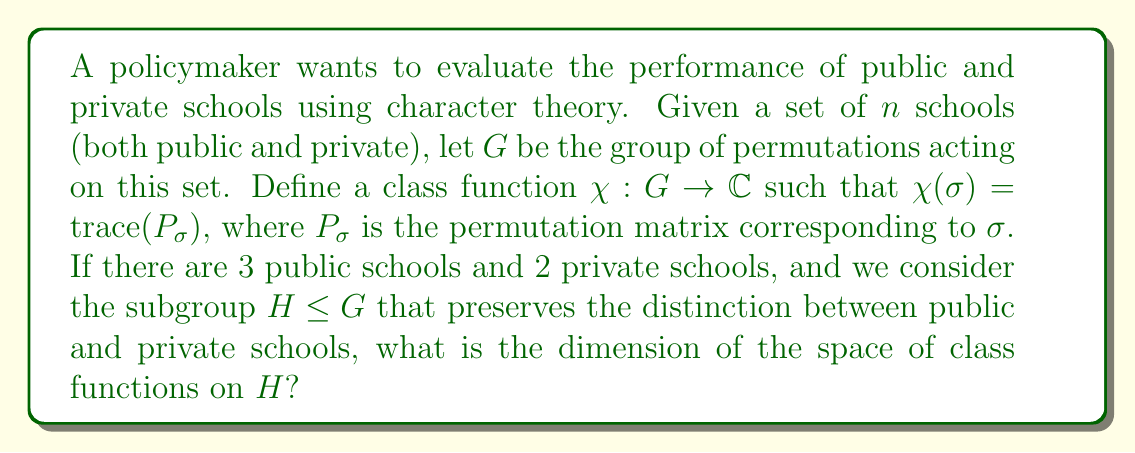What is the answer to this math problem? To solve this problem, we'll follow these steps:

1) First, we need to understand the structure of the subgroup $H$. It consists of permutations that preserve the distinction between public and private schools. This means $H \cong S_3 \times S_2$, where $S_3$ acts on the public schools and $S_2$ on the private schools.

2) The dimension of the space of class functions on a group is equal to the number of conjugacy classes in that group.

3) For $S_3$, there are 3 conjugacy classes:
   - Identity: (1)
   - Transpositions: (12), (13), (23)
   - 3-cycles: (123), (132)

4) For $S_2$, there are 2 conjugacy classes:
   - Identity: (1)
   - Transposition: (12)

5) In the direct product $H \cong S_3 \times S_2$, the conjugacy classes are formed by pairing each conjugacy class of $S_3$ with each conjugacy class of $S_2$. Therefore, the number of conjugacy classes in $H$ is the product of the number of conjugacy classes in $S_3$ and $S_2$.

6) Number of conjugacy classes in $H = 3 \times 2 = 6$

Therefore, the dimension of the space of class functions on $H$ is 6.
Answer: 6 